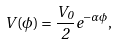<formula> <loc_0><loc_0><loc_500><loc_500>V ( \phi ) = \frac { V _ { 0 } } { 2 } e ^ { - \alpha \phi } ,</formula> 